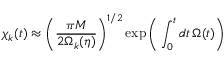<formula> <loc_0><loc_0><loc_500><loc_500>\chi _ { k } ( t ) \approx \left ( \frac { \pi M } { 2 \Omega _ { k } ( \eta ) } \right ) ^ { 1 / 2 } \exp \left ( \int _ { 0 } ^ { t } d t \, \Omega ( t ) \right )</formula> 